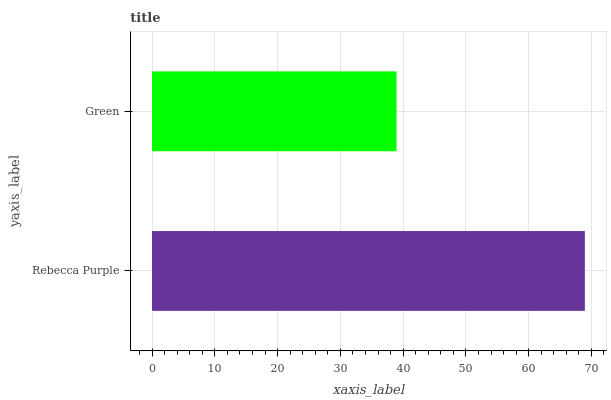Is Green the minimum?
Answer yes or no. Yes. Is Rebecca Purple the maximum?
Answer yes or no. Yes. Is Green the maximum?
Answer yes or no. No. Is Rebecca Purple greater than Green?
Answer yes or no. Yes. Is Green less than Rebecca Purple?
Answer yes or no. Yes. Is Green greater than Rebecca Purple?
Answer yes or no. No. Is Rebecca Purple less than Green?
Answer yes or no. No. Is Rebecca Purple the high median?
Answer yes or no. Yes. Is Green the low median?
Answer yes or no. Yes. Is Green the high median?
Answer yes or no. No. Is Rebecca Purple the low median?
Answer yes or no. No. 